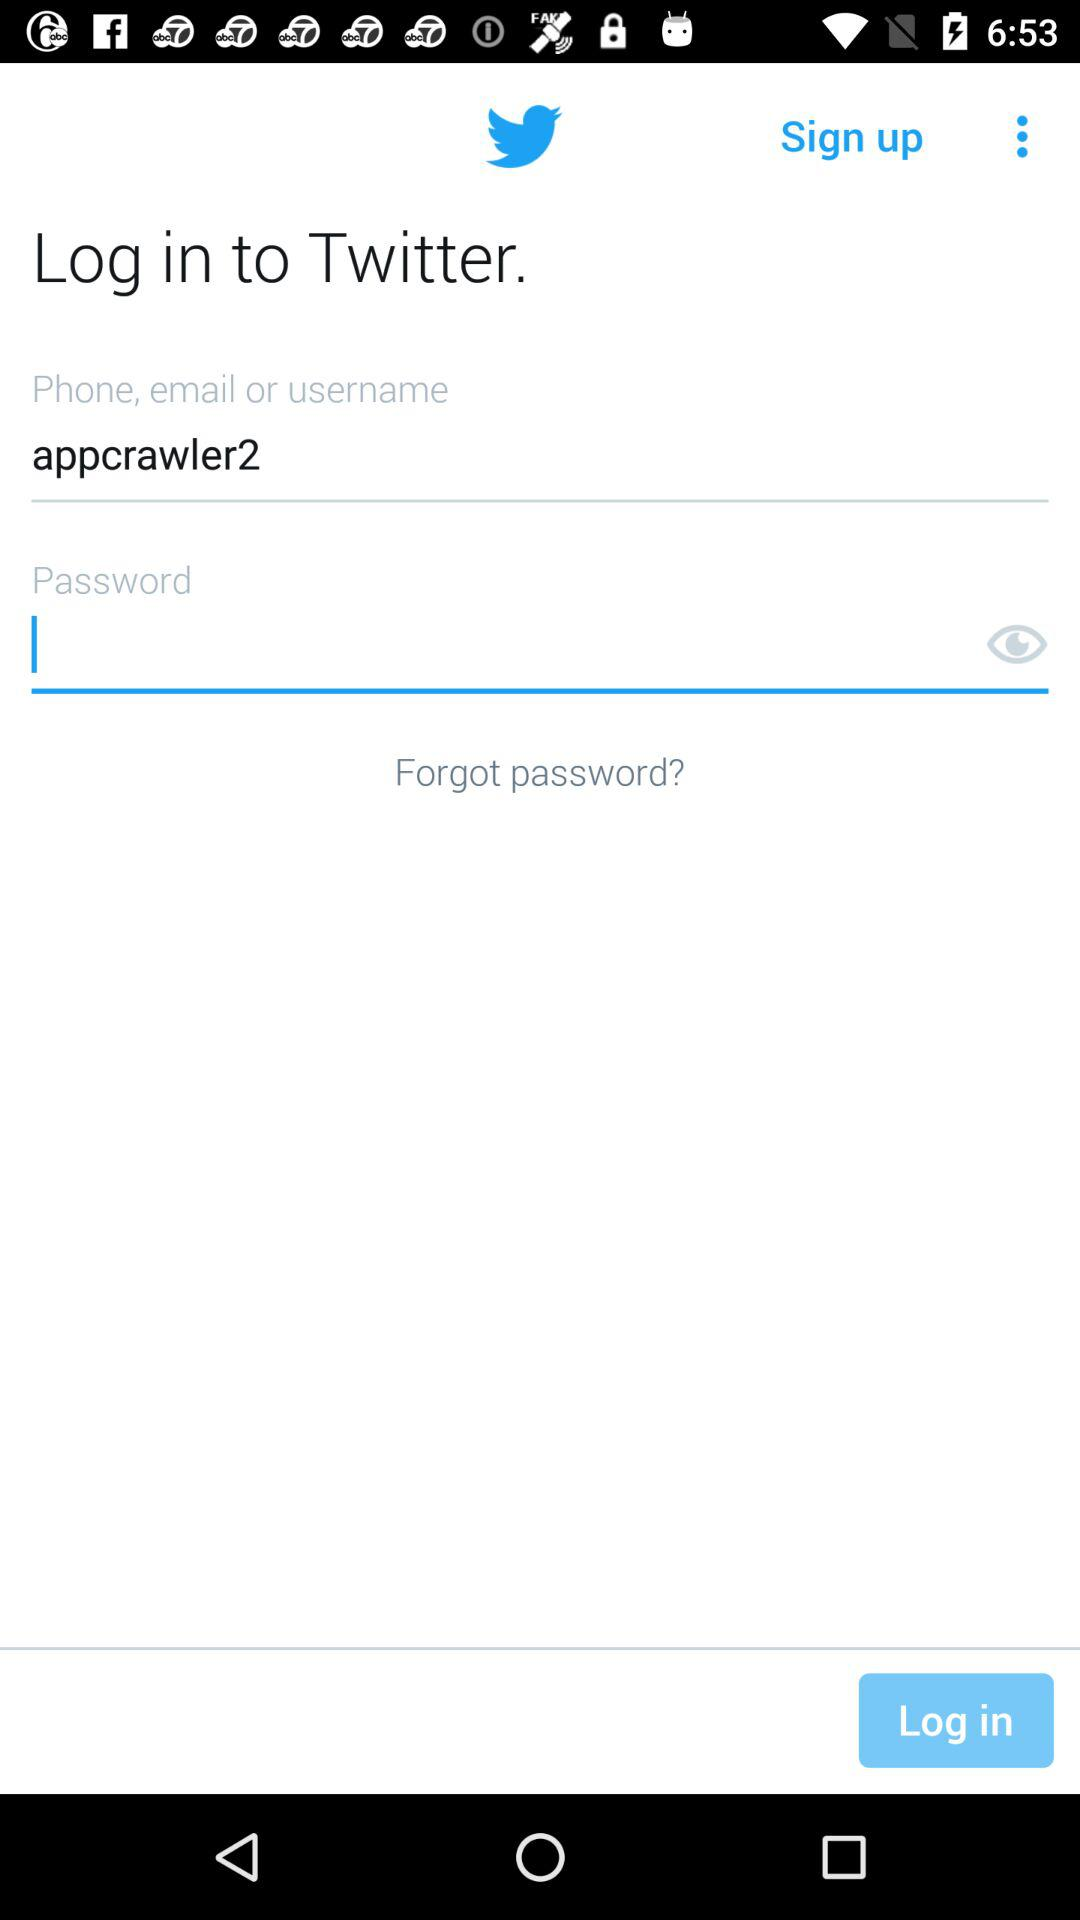How many characters are required to create a password?
When the provided information is insufficient, respond with <no answer>. <no answer> 